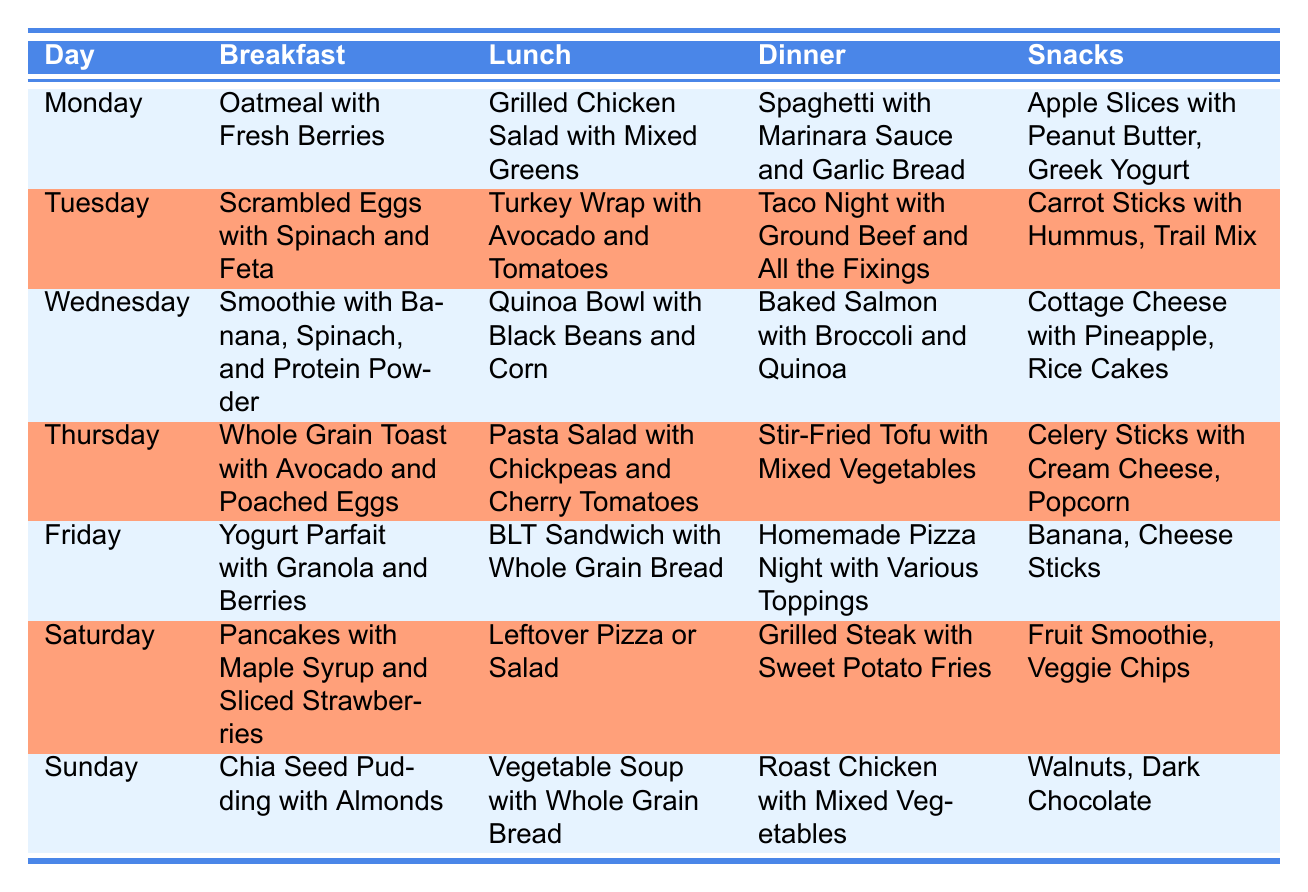What is the breakfast for Wednesday? The table shows that on Wednesday, the breakfast is "Smoothie with Banana, Spinach, and Protein Powder."
Answer: Smoothie with Banana, Spinach, and Protein Powder On which day is Taco Night scheduled for dinner? The table indicates that Taco Night is scheduled for dinner on Tuesday.
Answer: Tuesday How many snacks are listed for Thursday? There are two snacks listed for Thursday: "Celery Sticks with Cream Cheese" and "Popcorn." Therefore, the total number of snacks is 2.
Answer: 2 Which meal has grilled chicken in it? The lunch for Monday contains "Grilled Chicken Salad with Mixed Greens," identifying it as the meal with grilled chicken.
Answer: Grilled Chicken Salad with Mixed Greens What is the main difference in lunches between Friday and Sunday? On Friday, the lunch is a "BLT Sandwich with Whole Grain Bread," while on Sunday it is "Vegetable Soup with Whole Grain Bread." The main difference is that Friday's lunch is a sandwich, and Sunday's lunch is soup.
Answer: Sandwich vs. Soup How many different types of meals are served for snacks throughout the week? The total snacks listed are: "Apple Slices with Peanut Butter," "Greek Yogurt," "Carrot Sticks with Hummus," "Trail Mix," "Cottage Cheese with Pineapple," "Rice Cakes," "Celery Sticks with Cream Cheese," "Popcorn," "Banana," "Cheese Sticks," "Fruit Smoothie," "Veggie Chips," "Walnuts," and "Dark Chocolate." Counting unique items (without repetition), we have 14 different snacks.
Answer: 14 Is there a day without any vegetarian meals? Thursday features "Stir-Fried Tofu with Mixed Vegetables" as dinner, indicating at least one vegetarian option for that day. Additionally, Monday's lunch, Tuesday's dinner, and Wednesday's dinner also include vegetarian options. Therefore, there is no day without a vegetarian meal.
Answer: No What dinner option appears most frequently during the week? By examining all the dinners, "Spaghetti with Marinara Sauce and Garlic Bread," "Taco Night with Ground Beef and All the Fixings," "Baked Salmon with Broccoli and Quinoa," "Stir-Fried Tofu with Mixed Vegetables," "Homemade Pizza Night with Various Toppings," "Grilled Steak with Sweet Potato Fries," and "Roast Chicken with Mixed Vegetables," we see that "Homemade Pizza Night" is repeated most often as a popular family option; however, it only appears once. Thus, no dinner option appears more than once.
Answer: No dinner option is repeated 